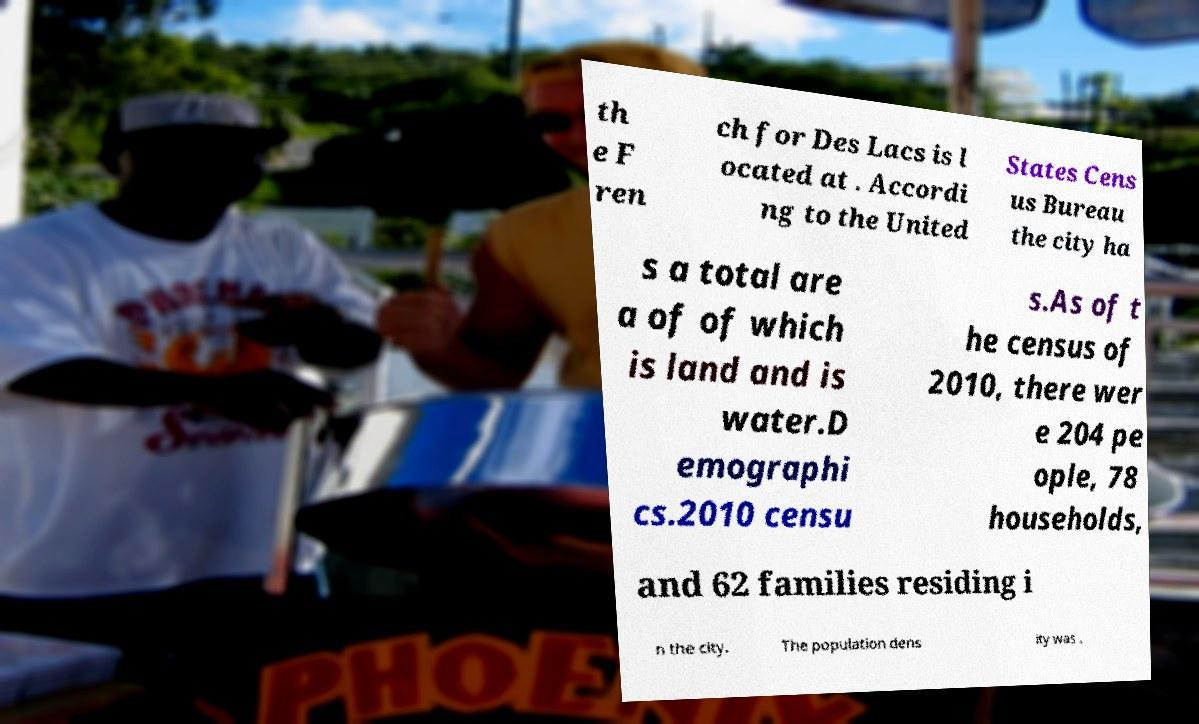Can you read and provide the text displayed in the image?This photo seems to have some interesting text. Can you extract and type it out for me? th e F ren ch for Des Lacs is l ocated at . Accordi ng to the United States Cens us Bureau the city ha s a total are a of of which is land and is water.D emographi cs.2010 censu s.As of t he census of 2010, there wer e 204 pe ople, 78 households, and 62 families residing i n the city. The population dens ity was . 